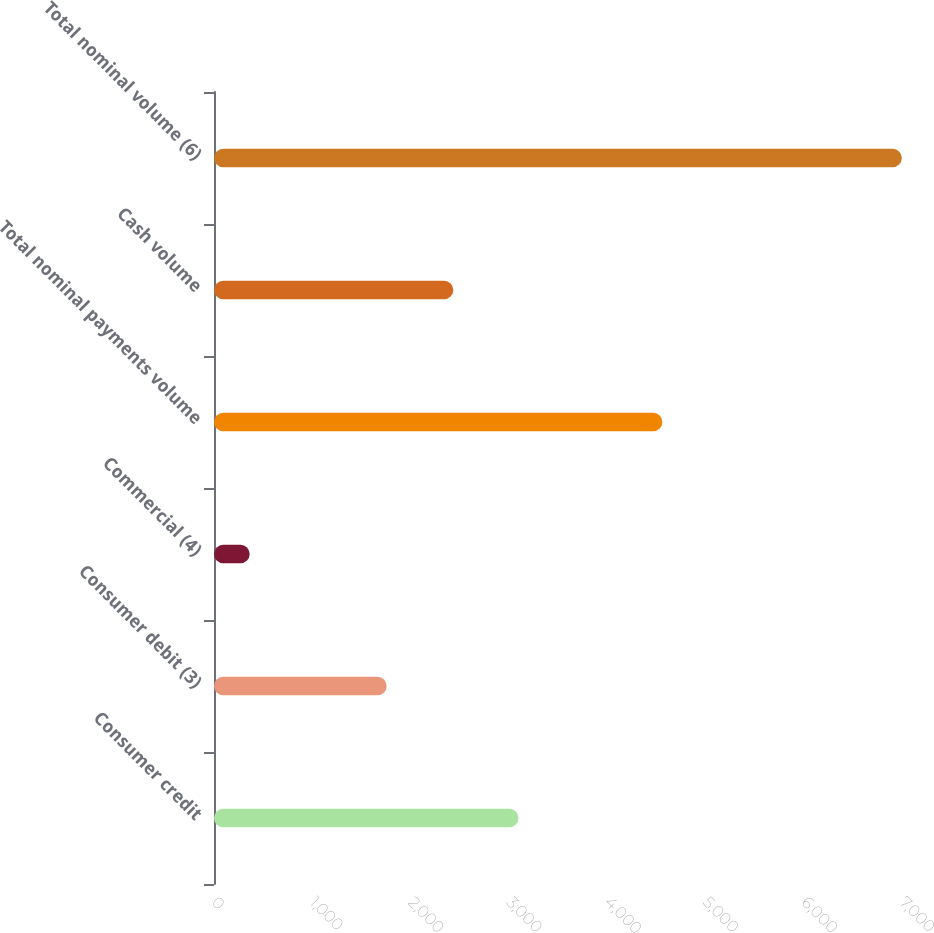Convert chart to OTSL. <chart><loc_0><loc_0><loc_500><loc_500><bar_chart><fcel>Consumer credit<fcel>Consumer debit (3)<fcel>Commercial (4)<fcel>Total nominal payments volume<fcel>Cash volume<fcel>Total nominal volume (6)<nl><fcel>3098.5<fcel>1757<fcel>363<fcel>4562<fcel>2435<fcel>6998<nl></chart> 